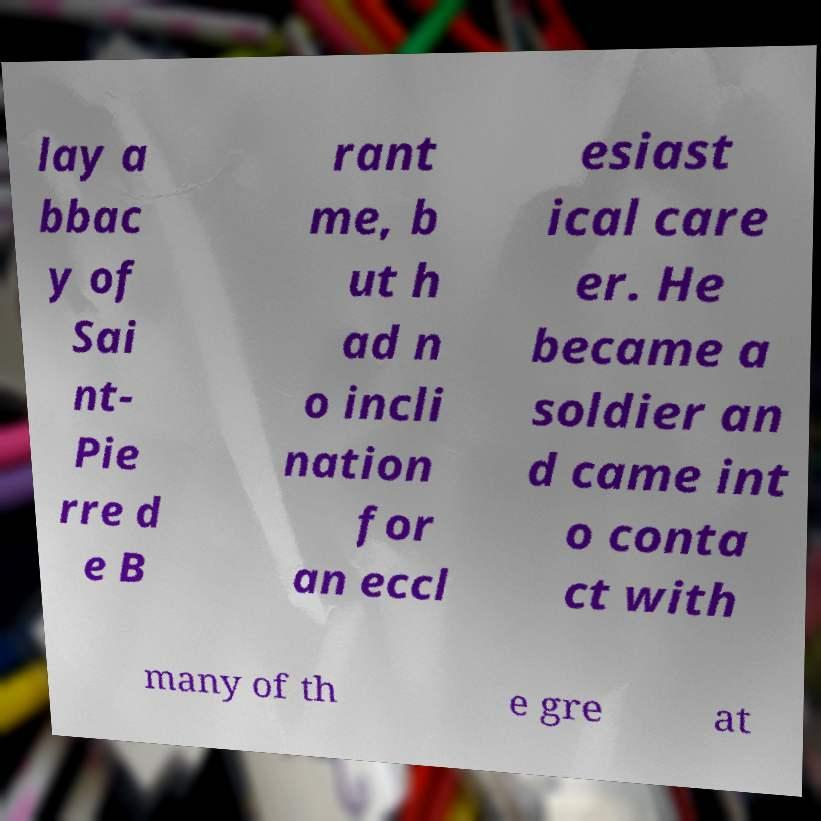I need the written content from this picture converted into text. Can you do that? lay a bbac y of Sai nt- Pie rre d e B rant me, b ut h ad n o incli nation for an eccl esiast ical care er. He became a soldier an d came int o conta ct with many of th e gre at 